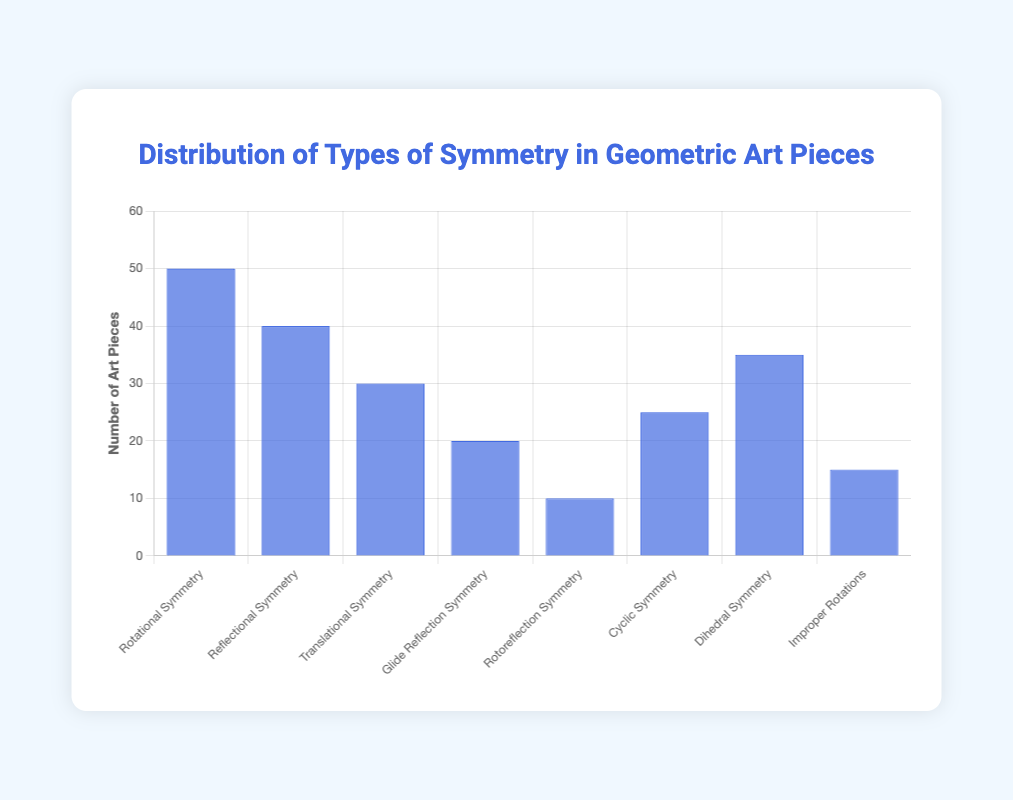Which type of symmetry is most common in the submitted geometric art pieces? The figure shows different types of symmetry with the heights of the blue bars representing the count of art pieces for each type. The tallest bar corresponds to Rotational Symmetry.
Answer: Rotational Symmetry Which two types of symmetry have the combined count of 65 art pieces? Adding the heights of the bars for Dihedral Symmetry (35) and Cyclic Symmetry (25) results in a total of 60, which is the closest to 65 among those analyzed.
Answer: Dihedral Symmetry and Cyclic Symmetry How many more art pieces exhibit Rotational Symmetry compared to Glide Reflection Symmetry? Subtract the count of Glide Reflection Symmetry (20) from the count of Rotational Symmetry (50). The difference is 30.
Answer: 30 What is the median value of the counts for all types of symmetry? List the counts in ascending order: 10, 15, 20, 25, 30, 35, 40, 50. The median is the average of the 4th and 5th values, (25 + 30) / 2.
Answer: 27.5 Which symmetry types have fewer than 20 art pieces each? Visually inspect the figure for bars shorter than the one corresponding to the count of 20. These are Rotoreflection Symmetry (10) and Improper Rotations (15).
Answer: Rotoreflection Symmetry and Improper Rotations How many types of symmetry have a count greater than 35 art pieces? Identify the bars that exceed 35 in height: Rotational Symmetry (50) and Reflectional Symmetry (40). There are two such types.
Answer: 2 Which type of symmetry has exactly half the count of Rotational Symmetry? Rotational Symmetry count is 50. Half of that is 25, which matches the height of Cyclic Symmetry's bar.
Answer: Cyclic Symmetry How does the count of Reflectional Symmetry compare to the count of Translational Symmetry? Reflectional Symmetry has a count of 40, while Translational Symmetry has a count of 30. Therefore, Reflectional Symmetry has 10 more art pieces.
Answer: Reflectional Symmetry has 10 more What is the total number of submitted art pieces with some form of symmetry? Sum up all the counts: 50 + 40 + 30 + 20 + 10 + 25 + 35 + 15. The total is 225.
Answer: 225 